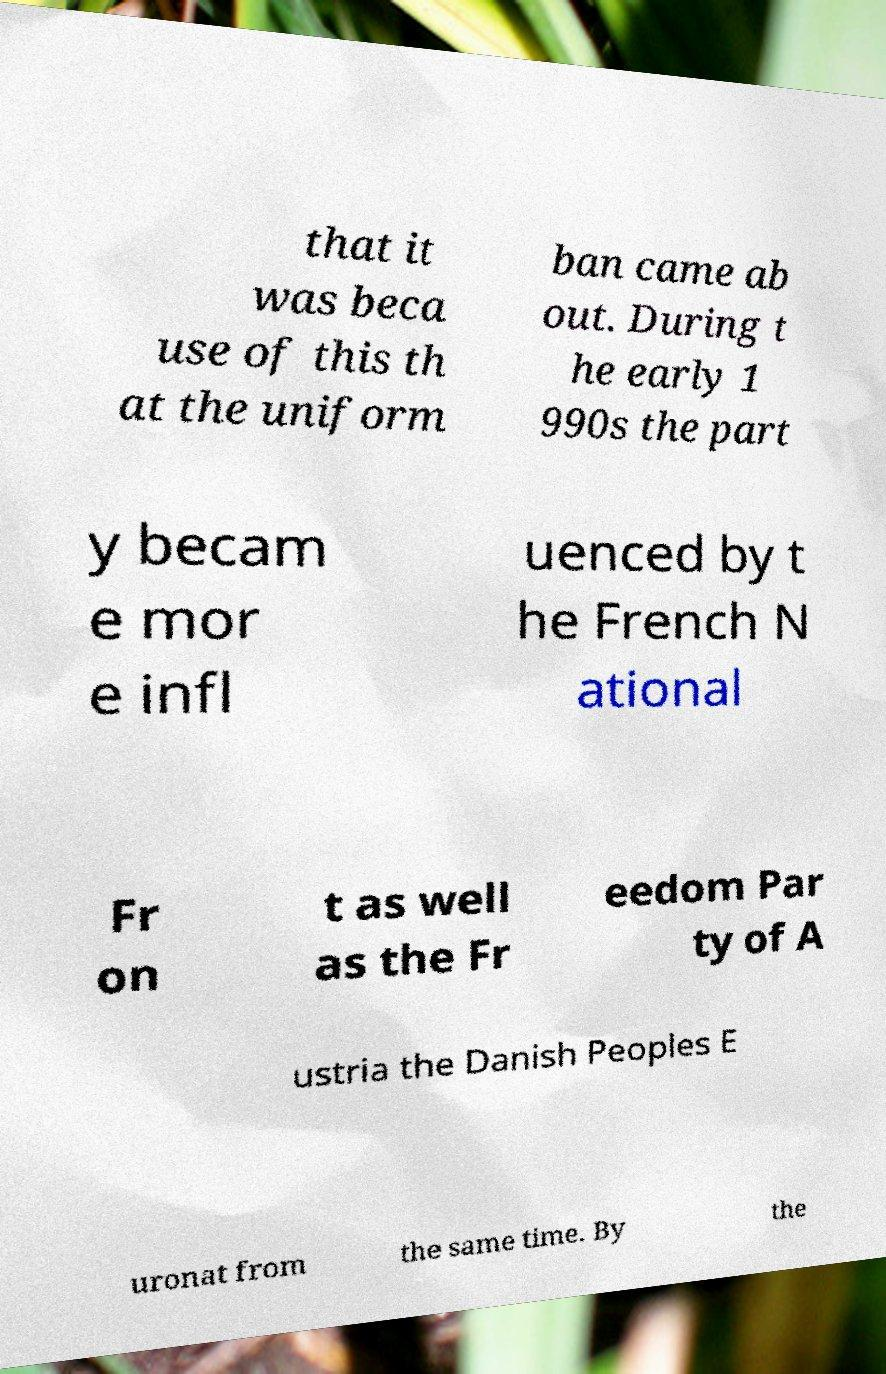Could you assist in decoding the text presented in this image and type it out clearly? that it was beca use of this th at the uniform ban came ab out. During t he early 1 990s the part y becam e mor e infl uenced by t he French N ational Fr on t as well as the Fr eedom Par ty of A ustria the Danish Peoples E uronat from the same time. By the 